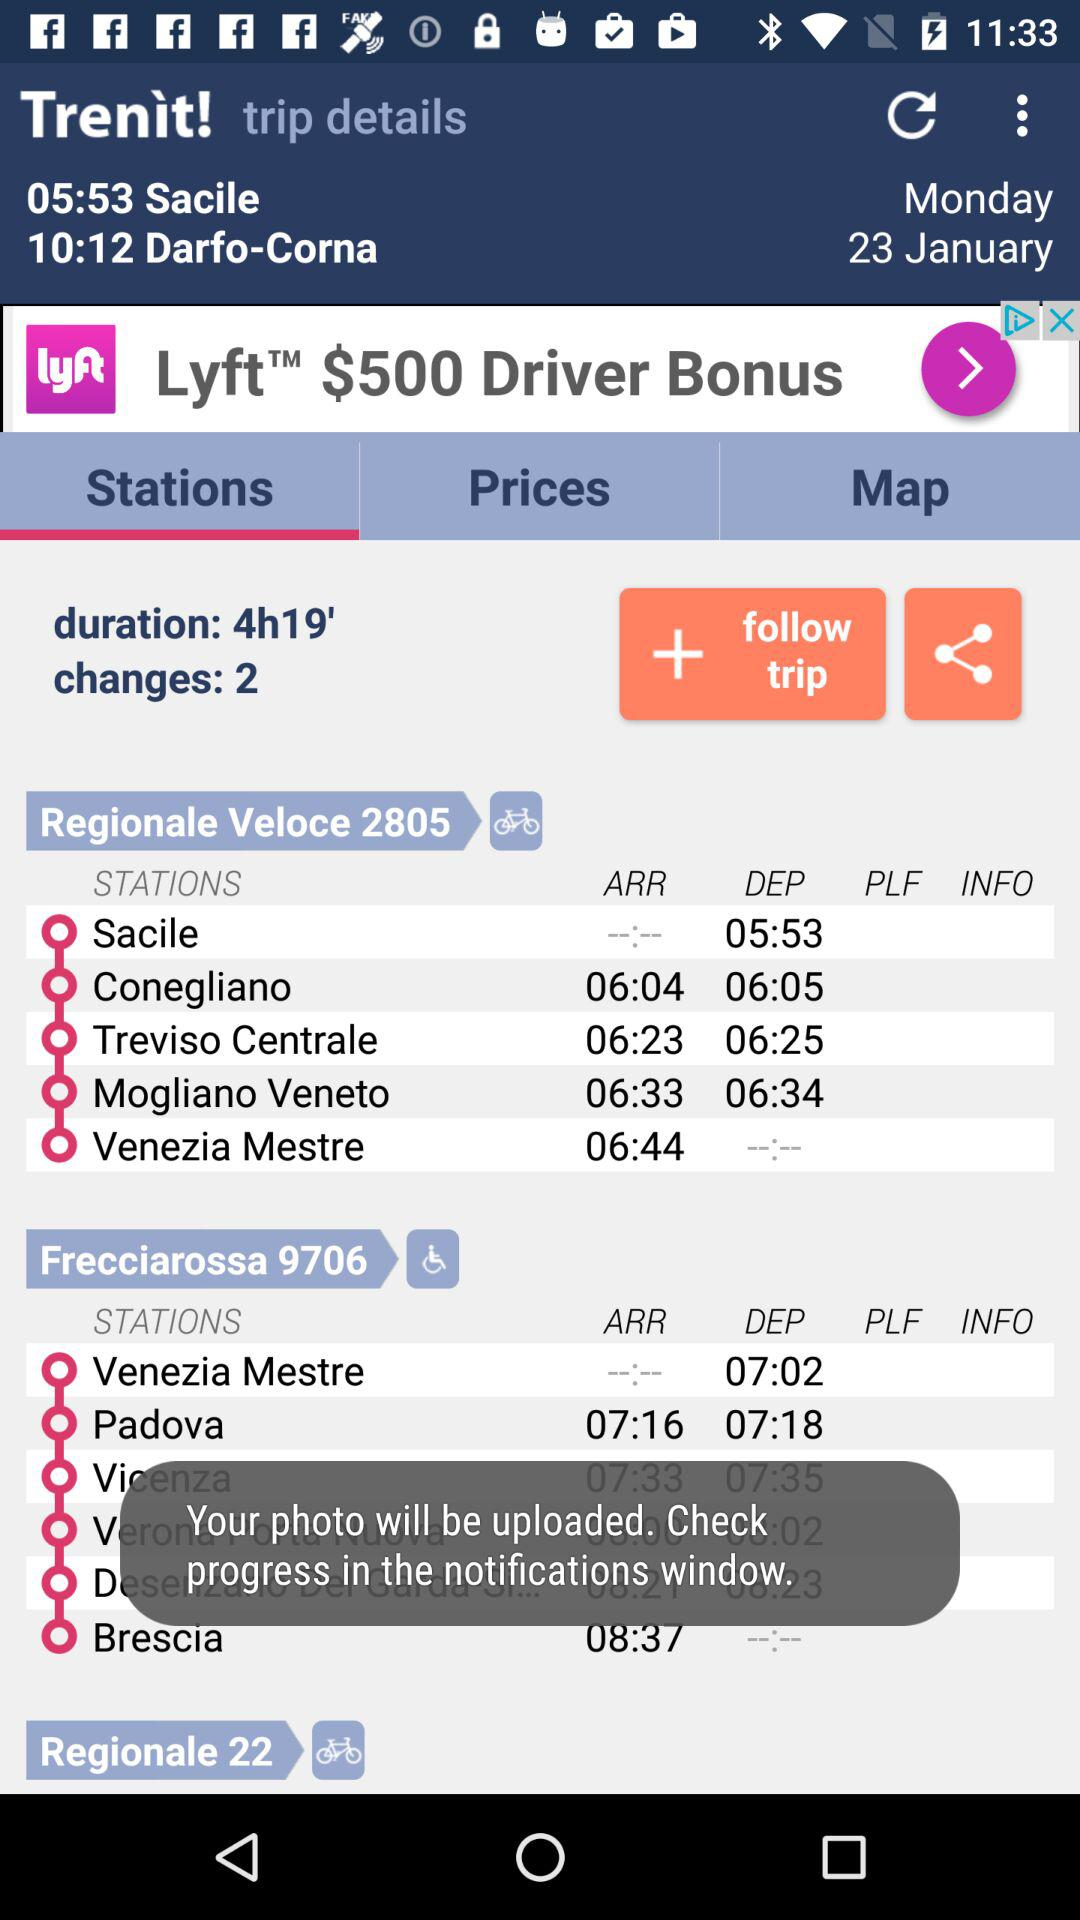What is the date of the trip? The date is Monday, January 23. 